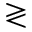Convert formula to latex. <formula><loc_0><loc_0><loc_500><loc_500>\gtrless</formula> 